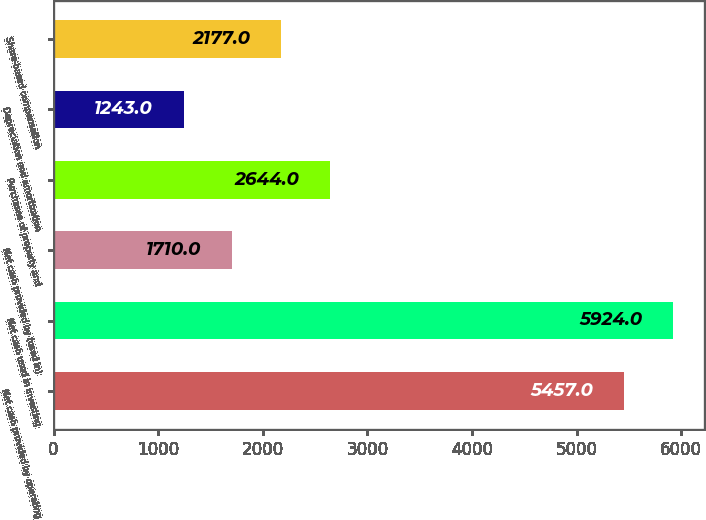<chart> <loc_0><loc_0><loc_500><loc_500><bar_chart><fcel>Net cash provided by operating<fcel>Net cash used in investing<fcel>Net cash provided by (used in)<fcel>Purchases of property and<fcel>Depreciation and amortization<fcel>Share-based compensation<nl><fcel>5457<fcel>5924<fcel>1710<fcel>2644<fcel>1243<fcel>2177<nl></chart> 